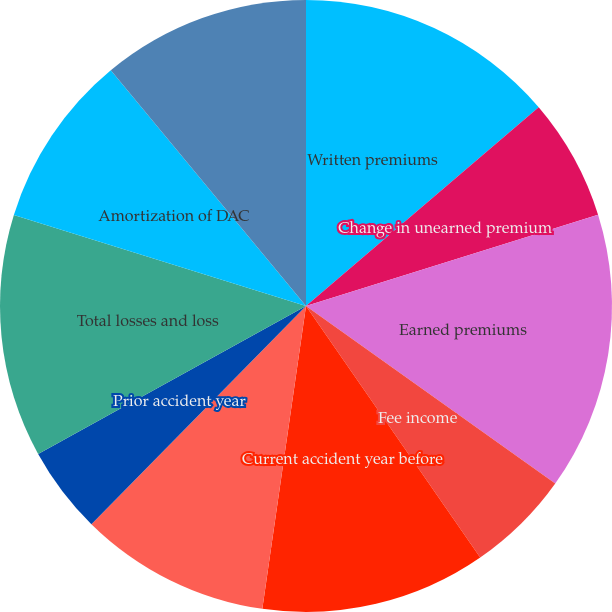<chart> <loc_0><loc_0><loc_500><loc_500><pie_chart><fcel>Written premiums<fcel>Change in unearned premium<fcel>Earned premiums<fcel>Fee income<fcel>Current accident year before<fcel>Current accident year<fcel>Prior accident year<fcel>Total losses and loss<fcel>Amortization of DAC<fcel>Underwriting expenses<nl><fcel>13.75%<fcel>6.43%<fcel>14.67%<fcel>5.51%<fcel>11.92%<fcel>10.09%<fcel>4.6%<fcel>12.84%<fcel>9.18%<fcel>11.01%<nl></chart> 